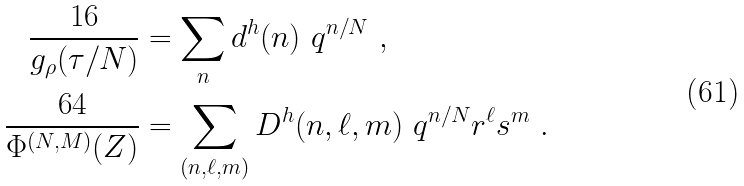<formula> <loc_0><loc_0><loc_500><loc_500>\frac { 1 6 } { g _ { \rho } ( \tau / N ) } & = \sum _ { n } d ^ { h } ( n ) \ q ^ { n / N } \ , \\ \frac { 6 4 } { \Phi ^ { ( N , M ) } ( Z ) } & = \sum _ { ( n , \ell , m ) } D ^ { h } ( n , \ell , m ) \ q ^ { n / N } r ^ { \ell } s ^ { m } \ .</formula> 